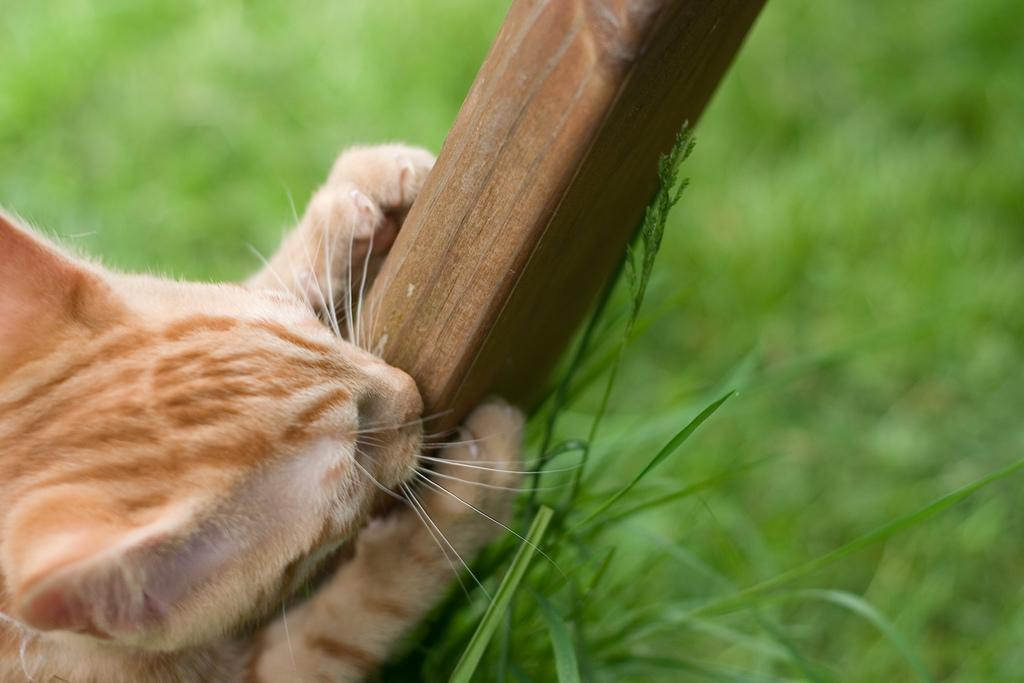What animal is present in the image? There is a cat in the picture. What is the cat holding in the image? The cat is holding a wooden stick. What type of surface is visible on the floor in the image? There is grass on the floor in the picture. Can you describe the background of the image? The backdrop is blurred. What type of story is the cat telling on the dock in the image? There is no dock present in the image, and the cat is not telling a story. 